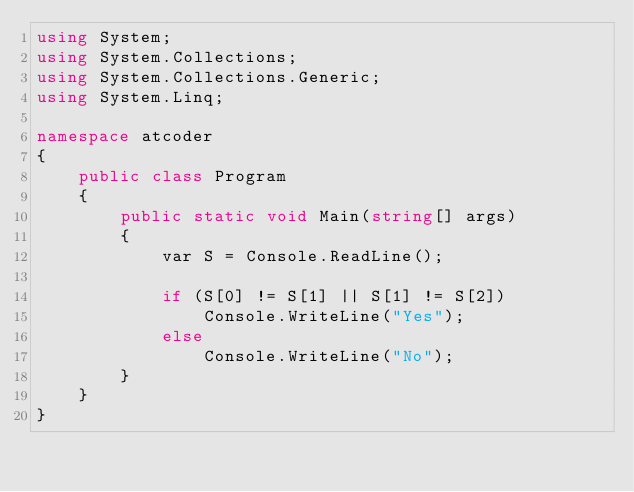<code> <loc_0><loc_0><loc_500><loc_500><_C#_>using System;
using System.Collections;
using System.Collections.Generic;
using System.Linq;

namespace atcoder
{
    public class Program
    {
        public static void Main(string[] args)
        {
            var S = Console.ReadLine();

            if (S[0] != S[1] || S[1] != S[2])
                Console.WriteLine("Yes");
            else
                Console.WriteLine("No");
        }
    }
}
</code> 